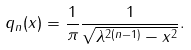Convert formula to latex. <formula><loc_0><loc_0><loc_500><loc_500>q _ { n } ( x ) = \frac { 1 } { \pi } \frac { 1 } { \sqrt { \lambda ^ { 2 ( n - 1 ) } - x ^ { 2 } } } .</formula> 